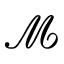Convert formula to latex. <formula><loc_0><loc_0><loc_500><loc_500>\mathcal { M }</formula> 